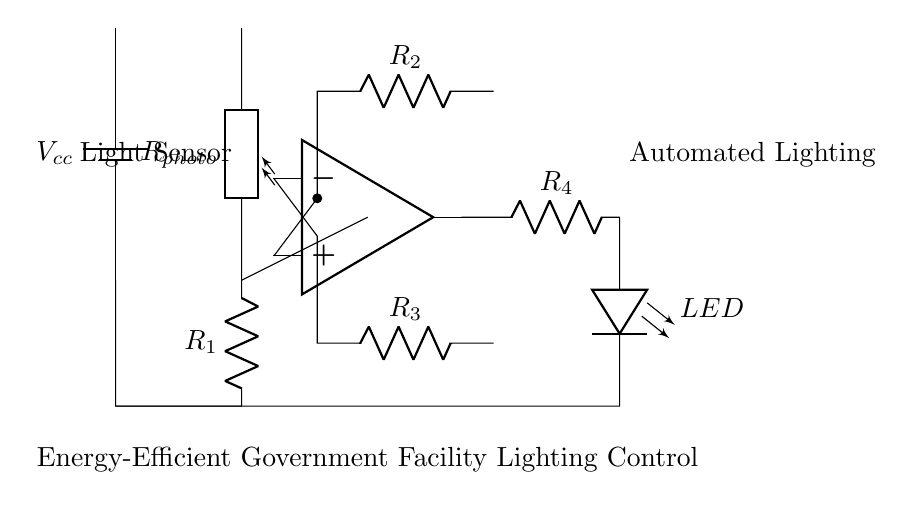What is the power supply voltage in this circuit? The power supply is indicated as Vcc, which typically represents the voltage applied to the circuit components. There is no specific voltage value represented in the diagram, but common values are 5V or 12V.
Answer: Vcc What component detects light in this circuit? The component labeled as Rphoto is the photoresistor, which is used to sense light levels and consequently adjust the circuit's operation based on ambient light conditions.
Answer: Photoresistor How many resistors are in this circuit? The circuit contains four resistors labeled as R1, R2, R3, and R4, which play roles in voltage division and feedback in the operational amplifier configuration.
Answer: Four What is the role of the operational amplifier in this circuit? The operational amplifier (op amp) amplifies the difference in voltage between its input terminals, based on the resistance values, enabling automatic control of the connected LED based on light detection from the photoresistor.
Answer: Amplification What would happen if the light level decreases? If the light level decreases, the resistance of the photoresistor increases, causing the voltage at the op amp's input to change; this can eventually turn on the LED, allowing it to illuminate based on preset thresholds.
Answer: LED turns on What does the LED indicate in this circuit? The LED represents the output action of the circuit, which turns on in response to low ambient light detected by the photoresistor, indicating that the automated lighting control is functioning.
Answer: Automated lighting 